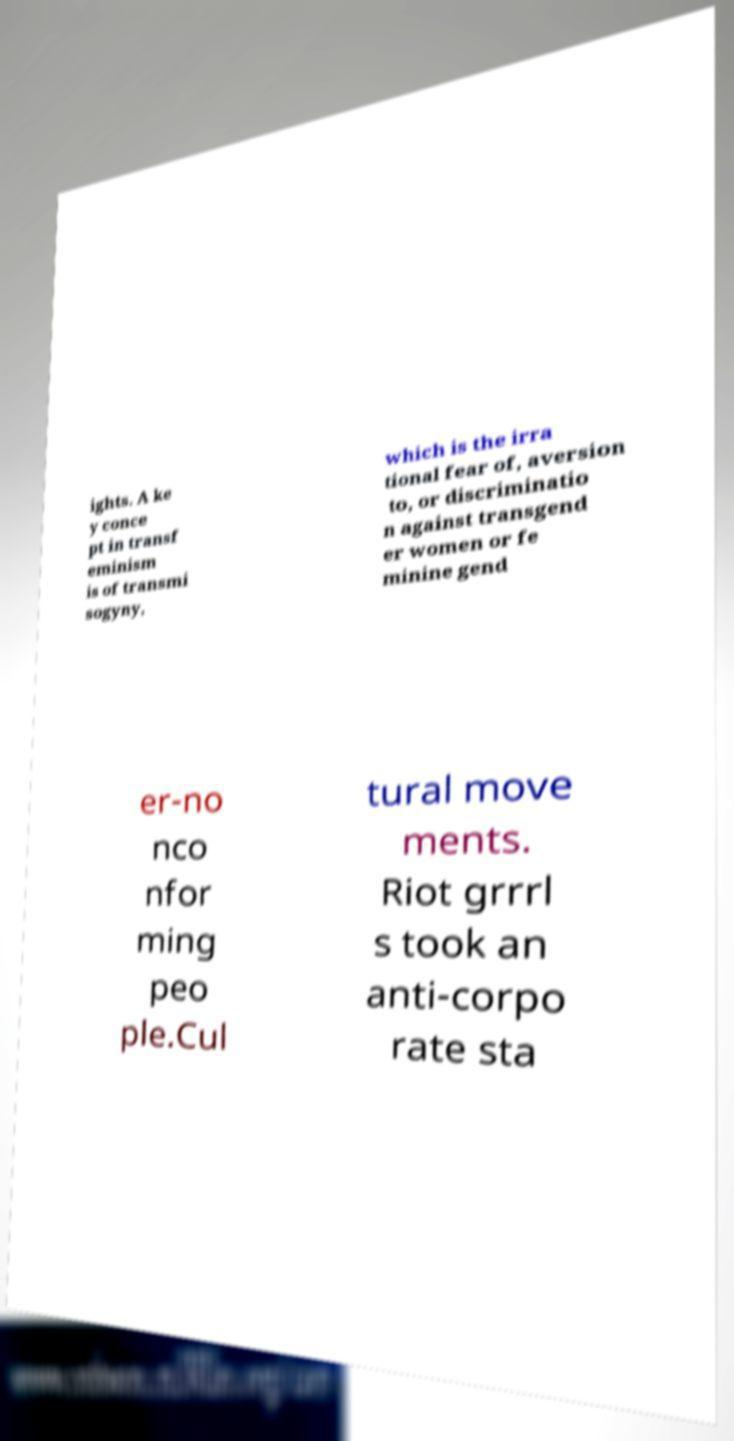What messages or text are displayed in this image? I need them in a readable, typed format. ights. A ke y conce pt in transf eminism is of transmi sogyny, which is the irra tional fear of, aversion to, or discriminatio n against transgend er women or fe minine gend er-no nco nfor ming peo ple.Cul tural move ments. Riot grrrl s took an anti-corpo rate sta 